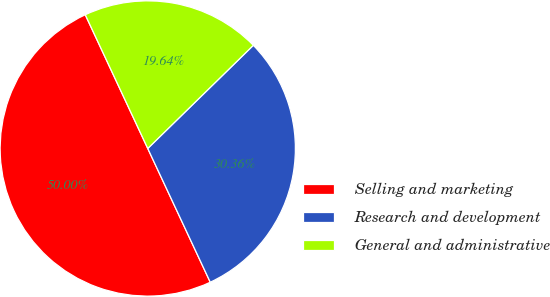<chart> <loc_0><loc_0><loc_500><loc_500><pie_chart><fcel>Selling and marketing<fcel>Research and development<fcel>General and administrative<nl><fcel>50.0%<fcel>30.36%<fcel>19.64%<nl></chart> 